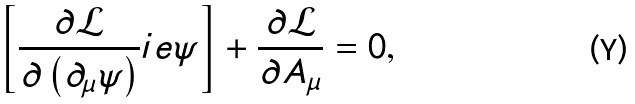<formula> <loc_0><loc_0><loc_500><loc_500>\left [ \frac { \partial \mathcal { L } } { \partial \left ( \partial _ { \mu } \psi \right ) } i e \psi \right ] + \frac { \partial \mathcal { L } } { \partial A _ { \mu } } = 0 ,</formula> 